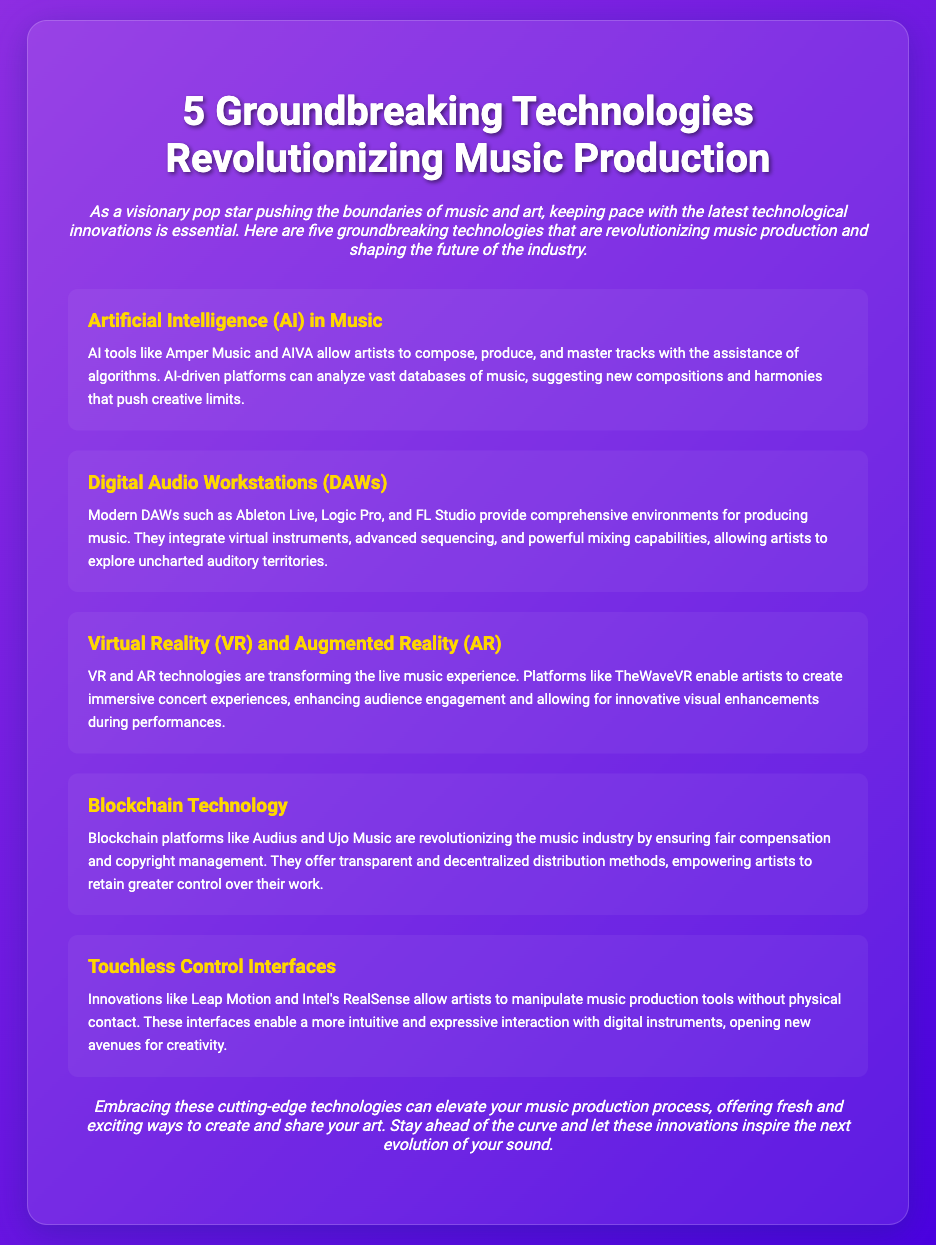what is the title of the document? The title of the document is given prominently at the top.
Answer: 5 Groundbreaking Technologies Revolutionizing Music Production how many technologies are listed? The document mentions five specific technologies that are highlighted.
Answer: 5 what is one platform that uses AI in music? The document mentions specific AI tools that assist in music production.
Answer: Amper Music which technology enhances audience engagement during live performances? The document states that VR and AR technologies transform live music experiences and enhance engagement.
Answer: Virtual Reality (VR) and Augmented Reality (AR) what does Blockchain Technology ensure for artists? The description mentions a primary benefit of blockchain platforms in the music industry.
Answer: Fair compensation which innovative interface allows touchless control for music production? The document provides examples of technologies that enable touchless interaction with music tools.
Answer: Leap Motion what is the primary function of Digital Audio Workstations (DAWs)? The document describes the main capabilities of DAWs in music production.
Answer: Comprehensive environments for producing music what is a benefit of using AI in music creation? The document outlines how AI tools assist artists in music composition and production.
Answer: Suggesting new compositions 